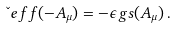Convert formula to latex. <formula><loc_0><loc_0><loc_500><loc_500>\L e f f ( - A _ { \mu } ) = - \epsilon g s ( A _ { \mu } ) \, .</formula> 